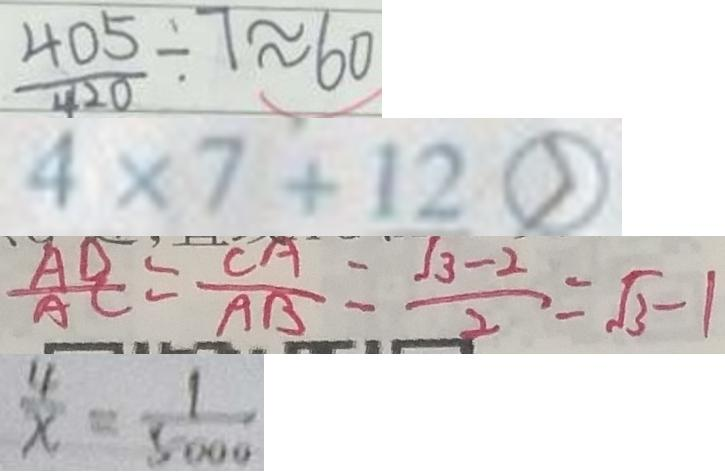<formula> <loc_0><loc_0><loc_500><loc_500>\frac { 4 0 5 } { 4 2 0 } \div 7 \approx 6 0 
 4 \times 7 + 1 2 > 
 \frac { A D } { A C } = \frac { C A } { A B } = \frac { \sqrt { 3 } - 2 } { 2 } = \sqrt { 3 } - 1 
 \frac { 4 } { x } = \frac { 1 } { 5 0 0 0 }</formula> 